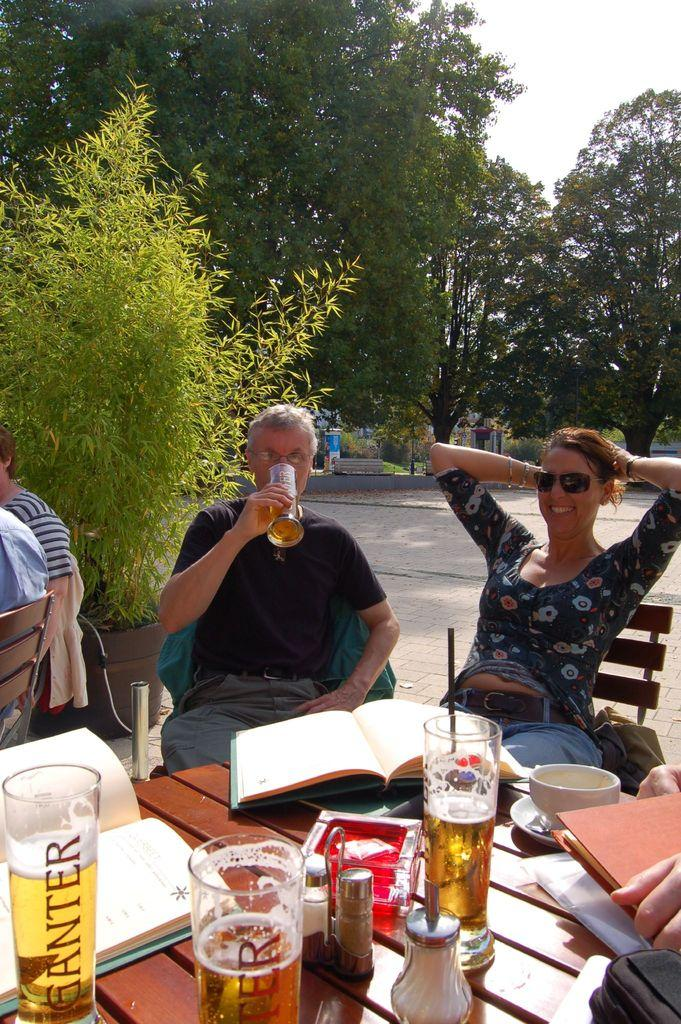How many people are in the image? There are two people in the image. What are the two people doing in the image? The two people are sitting in a chair. What is one of the people holding in the image? One of the people is drinking a beer. What is in front of the people in the image? There is a table in front of the people. What can be found on the table in the image? Food items and books are present on the table. What type of cave can be seen in the background of the image? There is no cave present in the image; it features two people sitting in a chair with a table in front of them. 